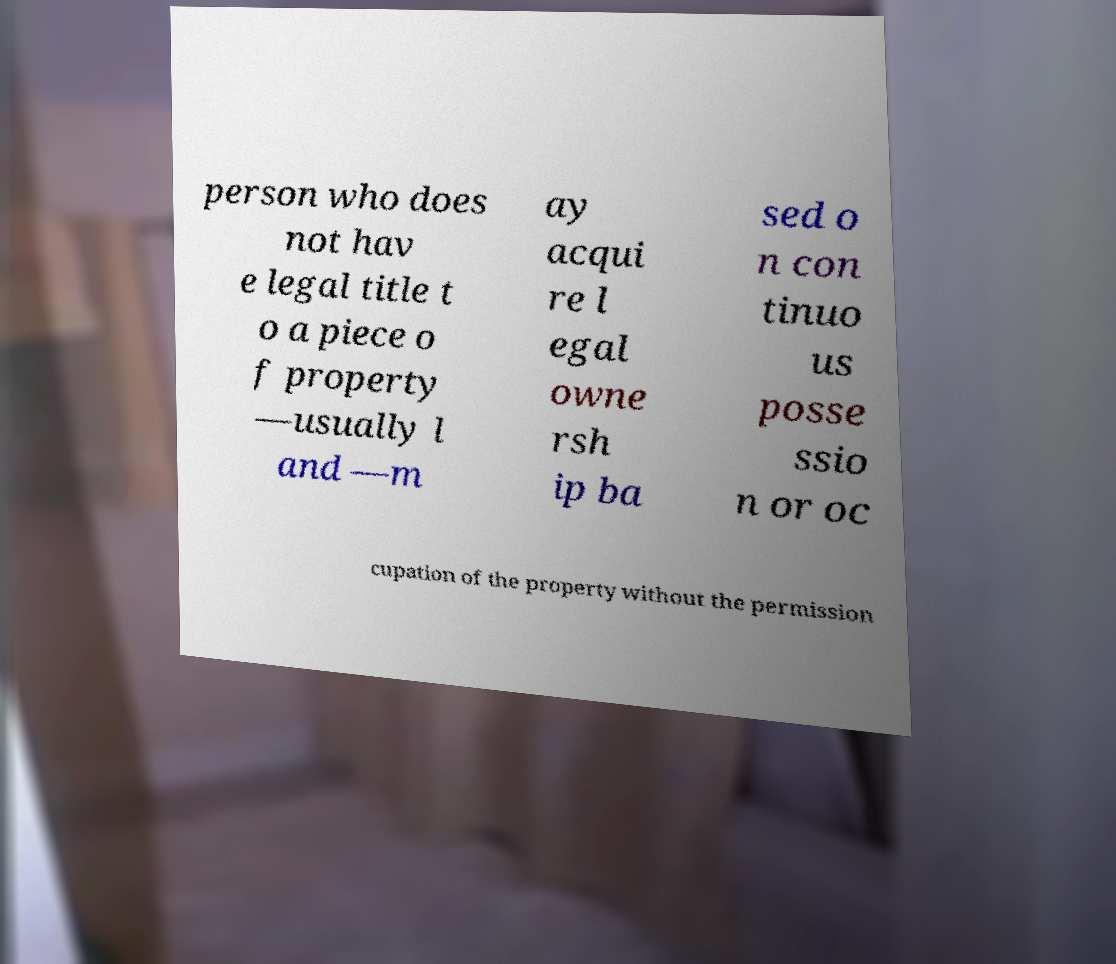Can you accurately transcribe the text from the provided image for me? person who does not hav e legal title t o a piece o f property —usually l and —m ay acqui re l egal owne rsh ip ba sed o n con tinuo us posse ssio n or oc cupation of the property without the permission 